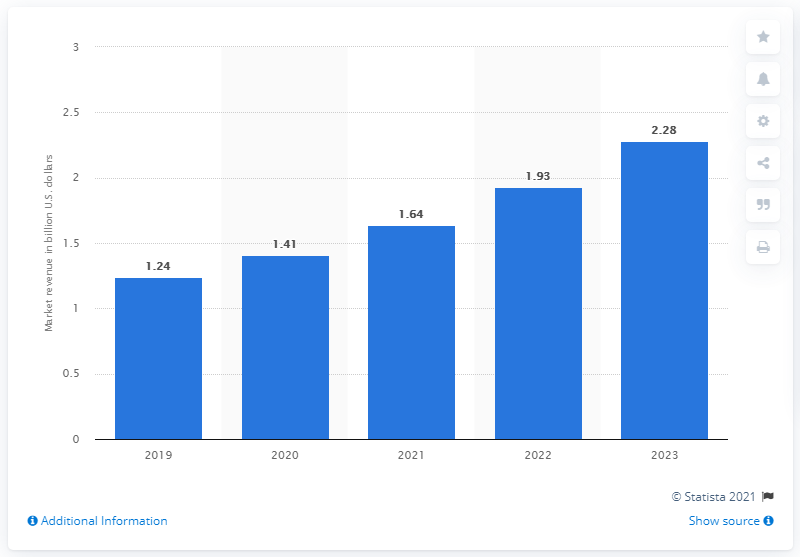Indicate a few pertinent items in this graphic. The projected revenue for the DLP market by the end of 2023 is expected to be approximately 2.28 billion dollars. 